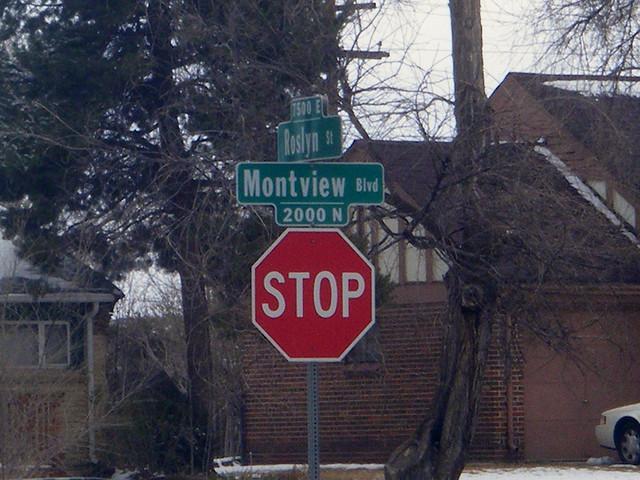What block number is this?
Quick response, please. 2000. What street corner is this?
Quick response, please. Montview and roslyn. Are there any people in the street?
Be succinct. No. Do cars in every direction stop?
Concise answer only. No. What does the red sign say?
Write a very short answer. Stop. 